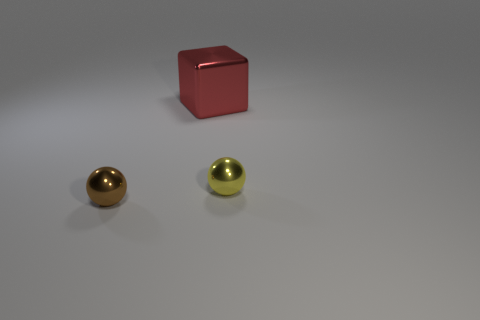Add 3 blocks. How many objects exist? 6 Subtract all balls. How many objects are left? 1 Add 1 purple balls. How many purple balls exist? 1 Subtract 0 green cylinders. How many objects are left? 3 Subtract all large red objects. Subtract all small brown shiny things. How many objects are left? 1 Add 3 small yellow spheres. How many small yellow spheres are left? 4 